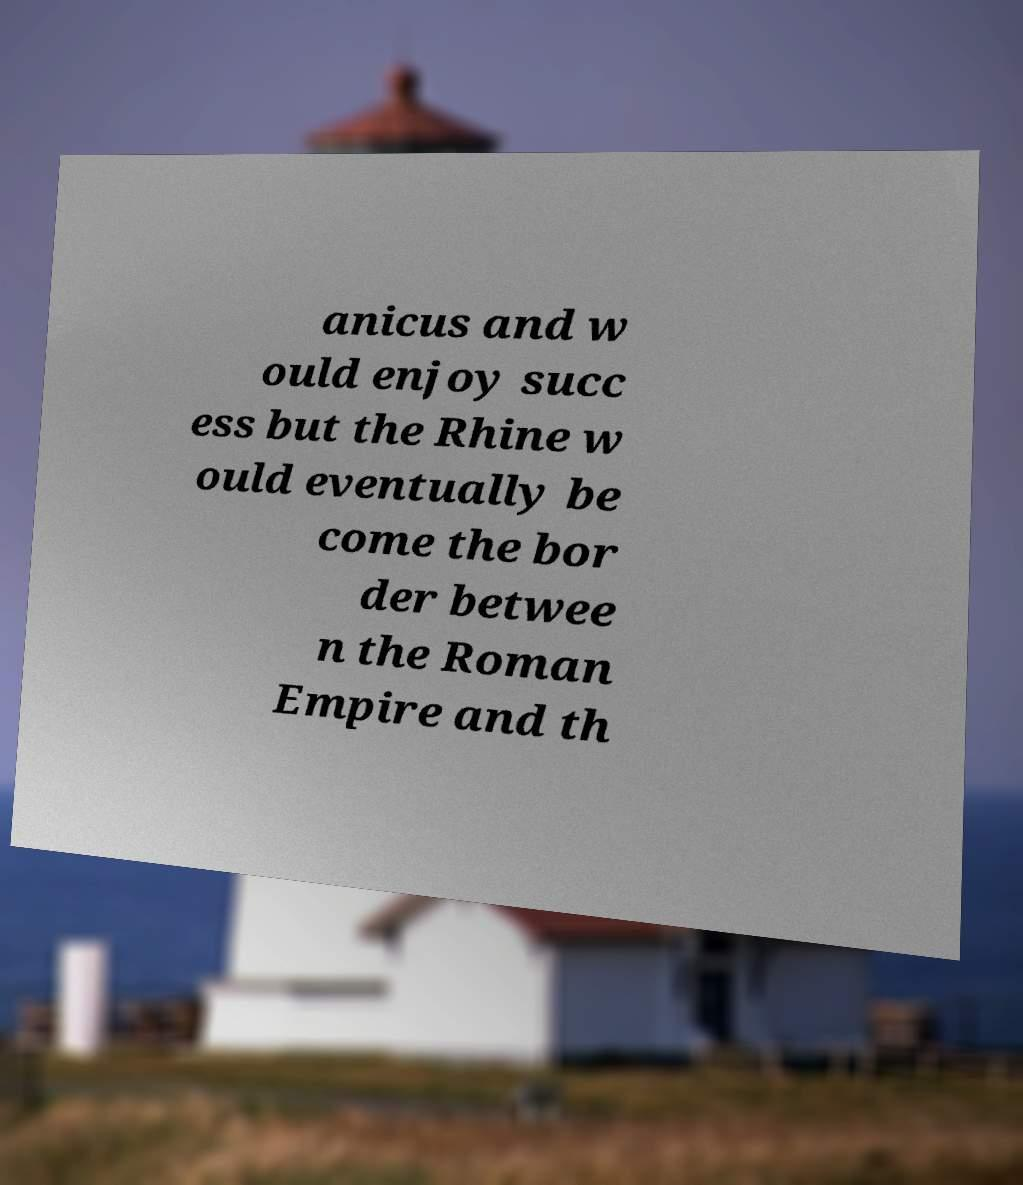Could you assist in decoding the text presented in this image and type it out clearly? anicus and w ould enjoy succ ess but the Rhine w ould eventually be come the bor der betwee n the Roman Empire and th 